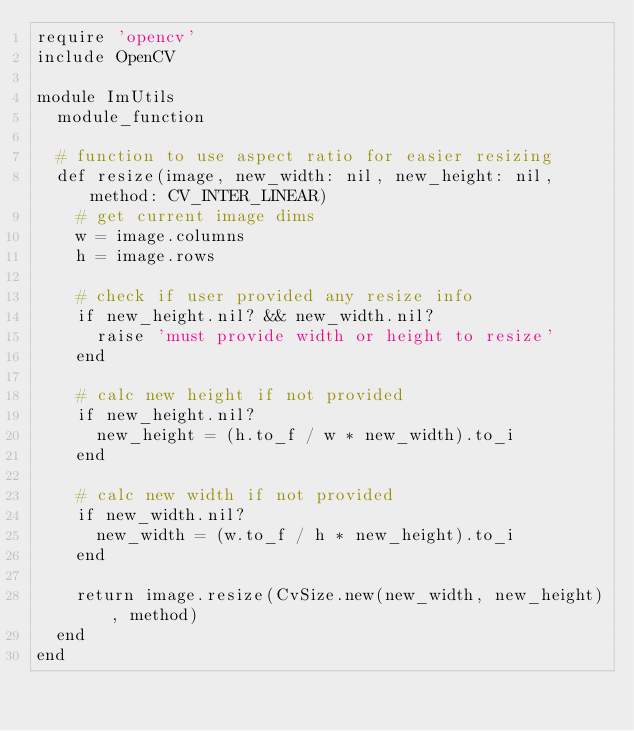<code> <loc_0><loc_0><loc_500><loc_500><_Ruby_>require 'opencv'
include OpenCV

module ImUtils
	module_function

	# function to use aspect ratio for easier resizing
	def resize(image, new_width: nil, new_height: nil, method: CV_INTER_LINEAR)
		# get current image dims
		w = image.columns
		h = image.rows

		# check if user provided any resize info
		if new_height.nil? && new_width.nil?
			raise 'must provide width or height to resize'
		end

		# calc new height if not provided
		if new_height.nil?
			new_height = (h.to_f / w * new_width).to_i
		end

		# calc new width if not provided
		if new_width.nil?
			new_width = (w.to_f / h * new_height).to_i
		end

		return image.resize(CvSize.new(new_width, new_height), method)
	end
end
</code> 